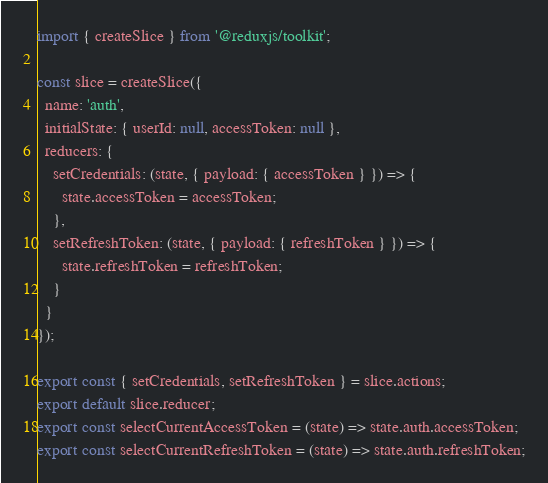Convert code to text. <code><loc_0><loc_0><loc_500><loc_500><_JavaScript_>import { createSlice } from '@reduxjs/toolkit';

const slice = createSlice({
  name: 'auth',
  initialState: { userId: null, accessToken: null },
  reducers: {
    setCredentials: (state, { payload: { accessToken } }) => {
      state.accessToken = accessToken;
    },
    setRefreshToken: (state, { payload: { refreshToken } }) => {
      state.refreshToken = refreshToken;
    }
  }
});

export const { setCredentials, setRefreshToken } = slice.actions;
export default slice.reducer;
export const selectCurrentAccessToken = (state) => state.auth.accessToken;
export const selectCurrentRefreshToken = (state) => state.auth.refreshToken;
</code> 